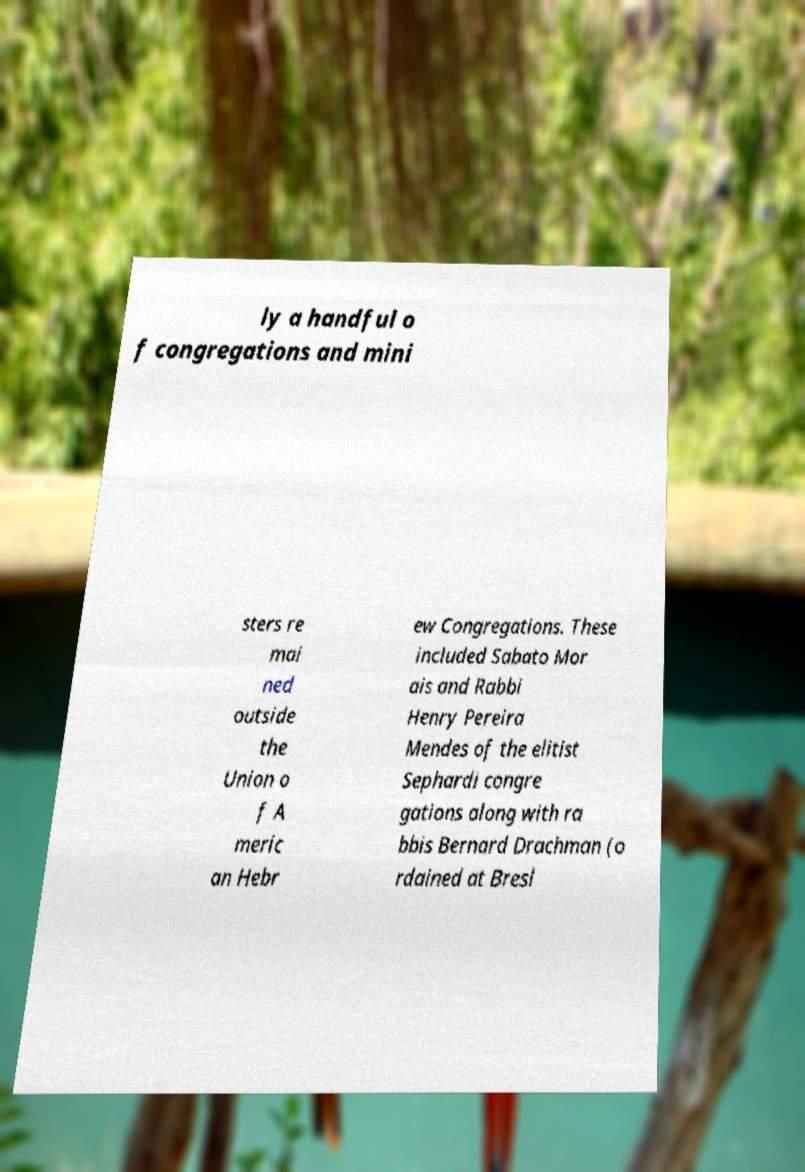There's text embedded in this image that I need extracted. Can you transcribe it verbatim? ly a handful o f congregations and mini sters re mai ned outside the Union o f A meric an Hebr ew Congregations. These included Sabato Mor ais and Rabbi Henry Pereira Mendes of the elitist Sephardi congre gations along with ra bbis Bernard Drachman (o rdained at Bresl 